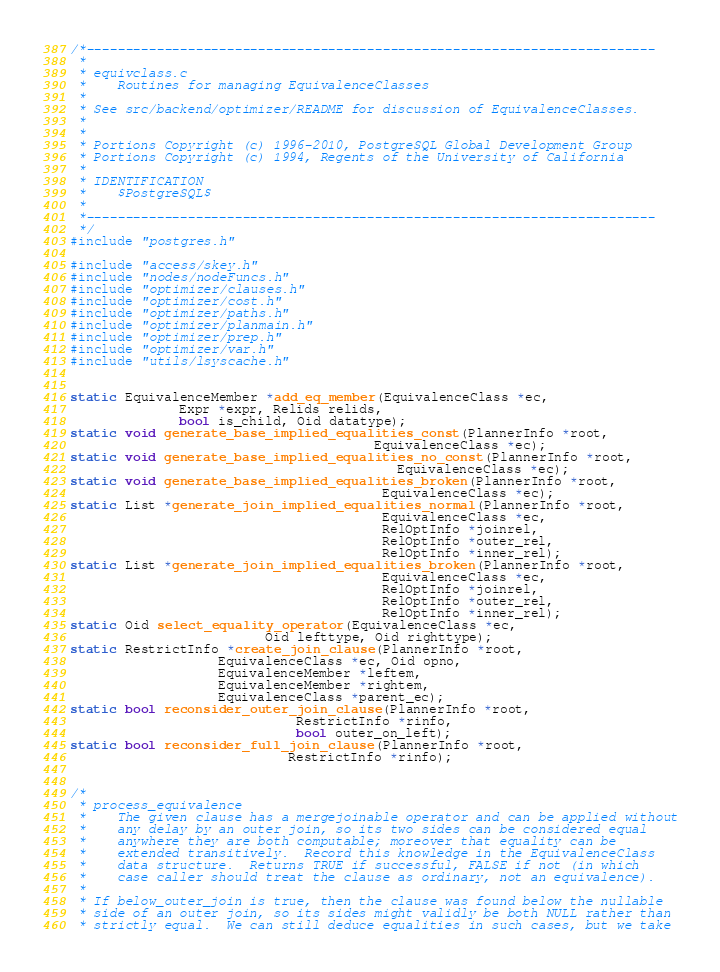Convert code to text. <code><loc_0><loc_0><loc_500><loc_500><_C_>/*-------------------------------------------------------------------------
 *
 * equivclass.c
 *	  Routines for managing EquivalenceClasses
 *
 * See src/backend/optimizer/README for discussion of EquivalenceClasses.
 *
 *
 * Portions Copyright (c) 1996-2010, PostgreSQL Global Development Group
 * Portions Copyright (c) 1994, Regents of the University of California
 *
 * IDENTIFICATION
 *	  $PostgreSQL$
 *
 *-------------------------------------------------------------------------
 */
#include "postgres.h"

#include "access/skey.h"
#include "nodes/nodeFuncs.h"
#include "optimizer/clauses.h"
#include "optimizer/cost.h"
#include "optimizer/paths.h"
#include "optimizer/planmain.h"
#include "optimizer/prep.h"
#include "optimizer/var.h"
#include "utils/lsyscache.h"


static EquivalenceMember *add_eq_member(EquivalenceClass *ec,
			  Expr *expr, Relids relids,
			  bool is_child, Oid datatype);
static void generate_base_implied_equalities_const(PlannerInfo *root,
									   EquivalenceClass *ec);
static void generate_base_implied_equalities_no_const(PlannerInfo *root,
										  EquivalenceClass *ec);
static void generate_base_implied_equalities_broken(PlannerInfo *root,
										EquivalenceClass *ec);
static List *generate_join_implied_equalities_normal(PlannerInfo *root,
										EquivalenceClass *ec,
										RelOptInfo *joinrel,
										RelOptInfo *outer_rel,
										RelOptInfo *inner_rel);
static List *generate_join_implied_equalities_broken(PlannerInfo *root,
										EquivalenceClass *ec,
										RelOptInfo *joinrel,
										RelOptInfo *outer_rel,
										RelOptInfo *inner_rel);
static Oid select_equality_operator(EquivalenceClass *ec,
						 Oid lefttype, Oid righttype);
static RestrictInfo *create_join_clause(PlannerInfo *root,
				   EquivalenceClass *ec, Oid opno,
				   EquivalenceMember *leftem,
				   EquivalenceMember *rightem,
				   EquivalenceClass *parent_ec);
static bool reconsider_outer_join_clause(PlannerInfo *root,
							 RestrictInfo *rinfo,
							 bool outer_on_left);
static bool reconsider_full_join_clause(PlannerInfo *root,
							RestrictInfo *rinfo);


/*
 * process_equivalence
 *	  The given clause has a mergejoinable operator and can be applied without
 *	  any delay by an outer join, so its two sides can be considered equal
 *	  anywhere they are both computable; moreover that equality can be
 *	  extended transitively.  Record this knowledge in the EquivalenceClass
 *	  data structure.  Returns TRUE if successful, FALSE if not (in which
 *	  case caller should treat the clause as ordinary, not an equivalence).
 *
 * If below_outer_join is true, then the clause was found below the nullable
 * side of an outer join, so its sides might validly be both NULL rather than
 * strictly equal.	We can still deduce equalities in such cases, but we take</code> 